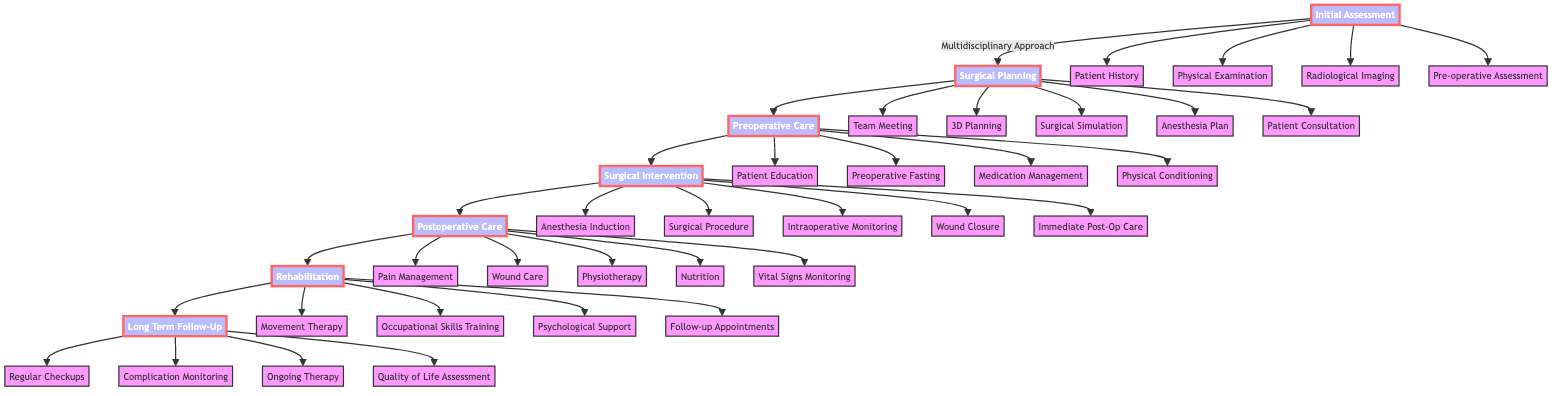What are the entities involved in initial assessment? The diagram specifies the entities involved in the Initial Assessment phase, which includes Plastic Surgery, Orthopedic Surgery, Radiology, Anesthesiology, Nursing, and Physical Therapy.
Answer: Plastic Surgery, Orthopedic Surgery, Radiology, Anesthesiology, Nursing, Physical Therapy How many steps are there in the surgical intervention phase? By counting the steps listed under the Surgical Intervention phase in the diagram, we find five steps: Anesthesia Induction, Surgical Procedure, Intraoperative Monitoring, Wound Closure, and Immediate Post-Op Care.
Answer: 5 Which phase comes before rehabilitation? The arrows in the diagram show a sequential flow from Postoperative Care to Rehabilitation, indicating that Postoperative Care is the phase that precedes Rehabilitation.
Answer: Postoperative Care What is the first step in the surgical planning phase? The first step listed in the Surgical Planning phase is the Multidisciplinary Team Meeting, which is clearly indicated at the top of this phase.
Answer: Multidisciplinary Team Meeting What are the entities involved in postoperative care? The diagram notes that the entities involved in the Postoperative Care phase include Nursing, Anesthesiology, Physical Therapy, Plastic Surgery, and Pharmacy.
Answer: Nursing, Anesthesiology, Physical Therapy, Plastic Surgery, Pharmacy How many entities are involved in the initial assessment? Counting the list of entities in the Initial Assessment phase reveals six participants: Plastic Surgery, Orthopedic Surgery, Radiology, Anesthesiology, Nursing, and Physical Therapy.
Answer: 6 What step follows the patient education in preoperative care? According to the flow of steps in the Preoperative Care phase, after Patient Education, the next step is Preoperative Fasting.
Answer: Preoperative Fasting What is the last step in the long-term follow-up phase? The final step in the Long-Term Follow-Up phase, as indicated in the diagram, is Quality of Life Assessment.
Answer: Quality of Life Assessment 